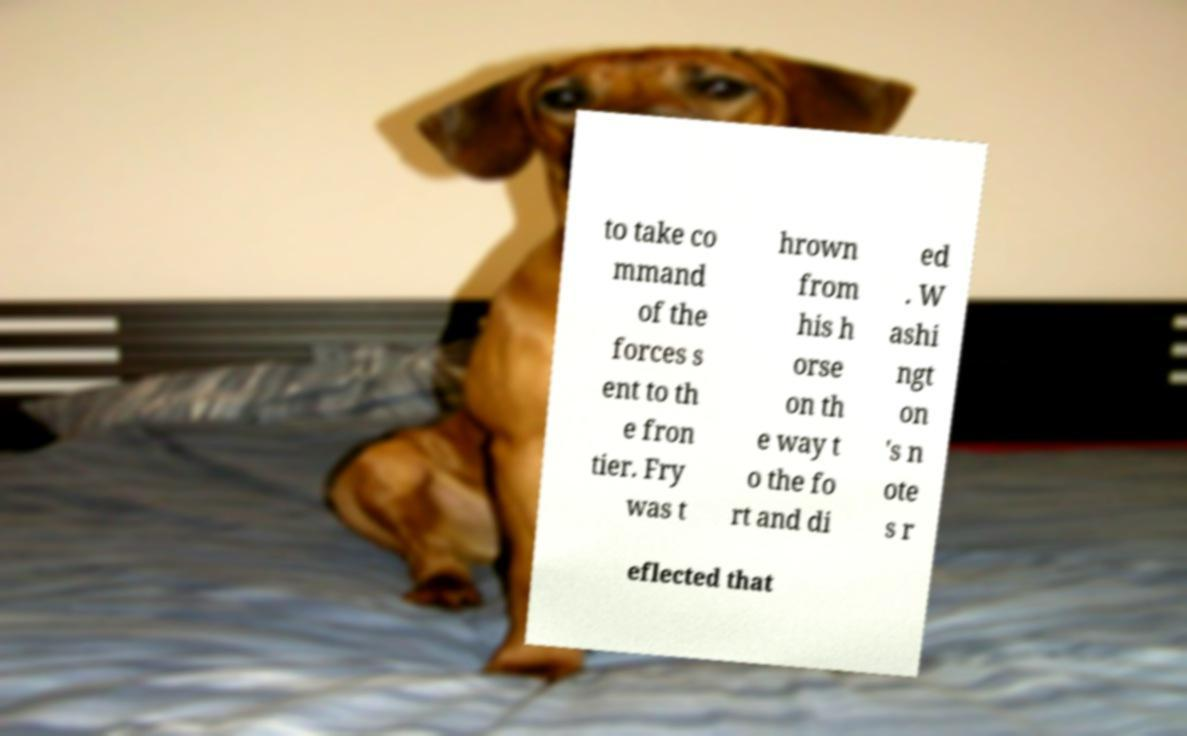Could you assist in decoding the text presented in this image and type it out clearly? to take co mmand of the forces s ent to th e fron tier. Fry was t hrown from his h orse on th e way t o the fo rt and di ed . W ashi ngt on 's n ote s r eflected that 